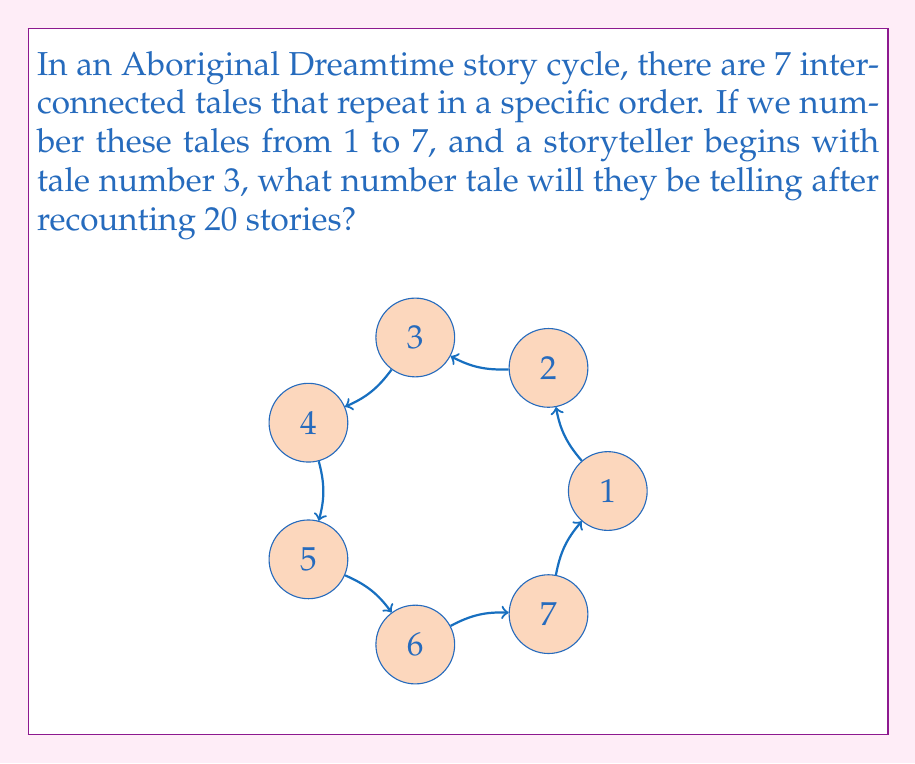Solve this math problem. To solve this problem, we can use modular arithmetic, which is perfect for analyzing cyclical patterns like those found in Dreamtime stories.

1) First, we need to understand that after telling 7 stories, the cycle repeats. This means we're working in modulo 7.

2) The storyteller starts at tale 3 and tells 20 stories. We can represent this mathematically as:

   $$(3 + 19) \pmod{7}$$

   We add 19 instead of 20 because the starting tale (3) is included in the count of 20.

3) Simplify the addition inside the parentheses:

   $$22 \pmod{7}$$

4) To find the result of 22 mod 7, we divide 22 by 7 and take the remainder:

   $$22 = 3 \times 7 + 1$$

   The remainder is 1.

5) Therefore, after telling 20 stories, the storyteller will be on tale number 1 in the cycle.

This cyclical nature reflects the continuous, interconnected worldview present in many Aboriginal cultures, where stories and events are seen as part of an ongoing, repeating cycle rather than a linear progression.
Answer: $1 \pmod{7}$ 